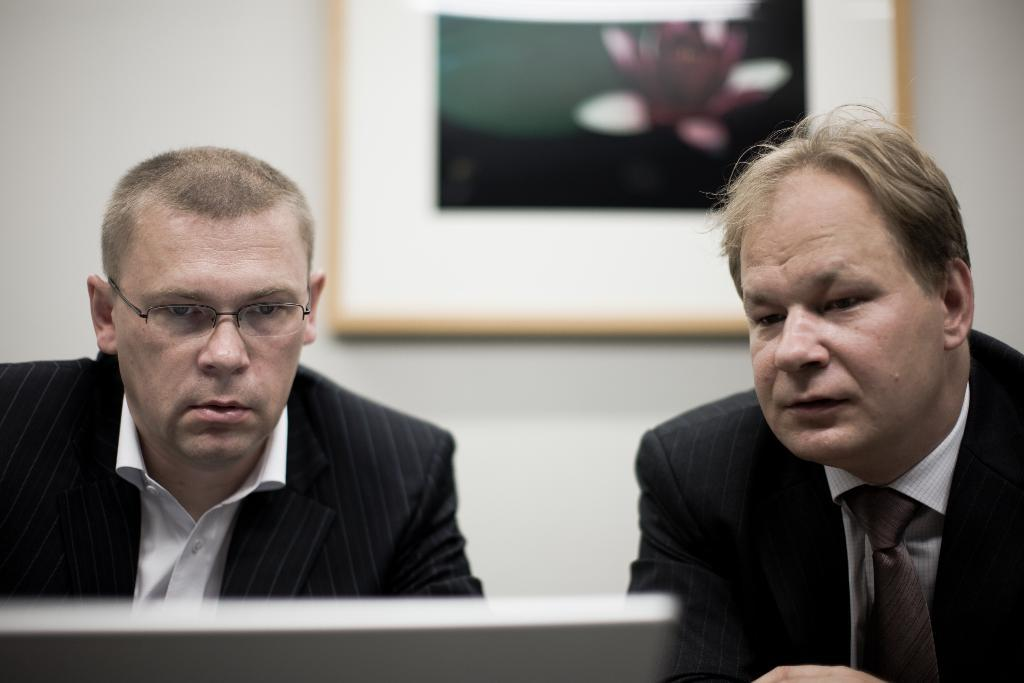How many people are present in the image? There are two people sitting in the image. What are the people wearing? The people are wearing suits. What is in front of the people? There is a screen in front of the people. What can be seen on the wall in the background? There is a photo frame on a wall in the background. What type of scent can be smelled coming from the oven in the image? There is no oven present in the image, so it is not possible to smell any scent. 